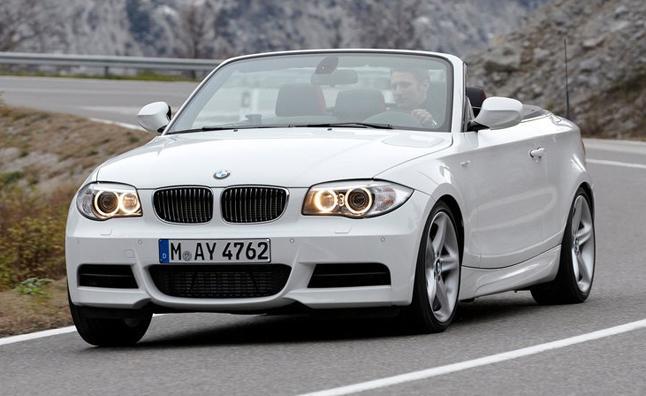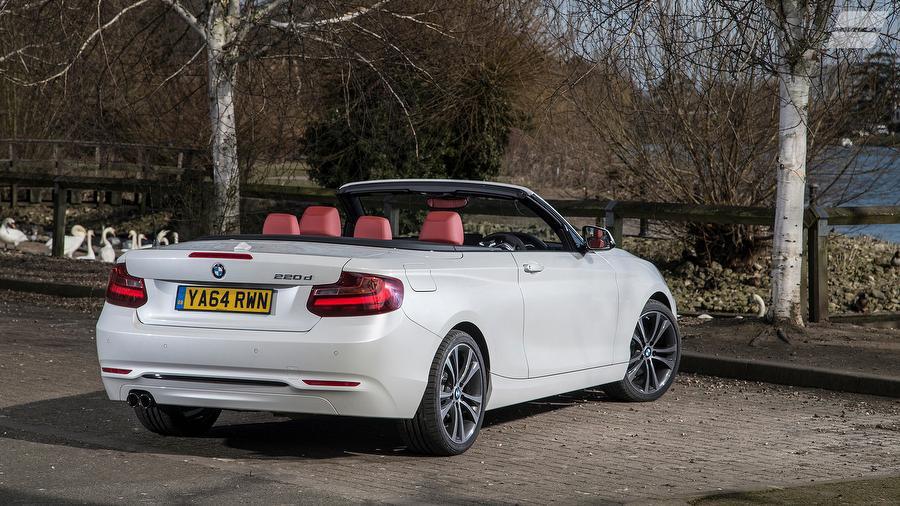The first image is the image on the left, the second image is the image on the right. Considering the images on both sides, is "Left image shows a white convertible driving down a paved road." valid? Answer yes or no. Yes. The first image is the image on the left, the second image is the image on the right. Analyze the images presented: Is the assertion "One of ther cars is blue." valid? Answer yes or no. No. 